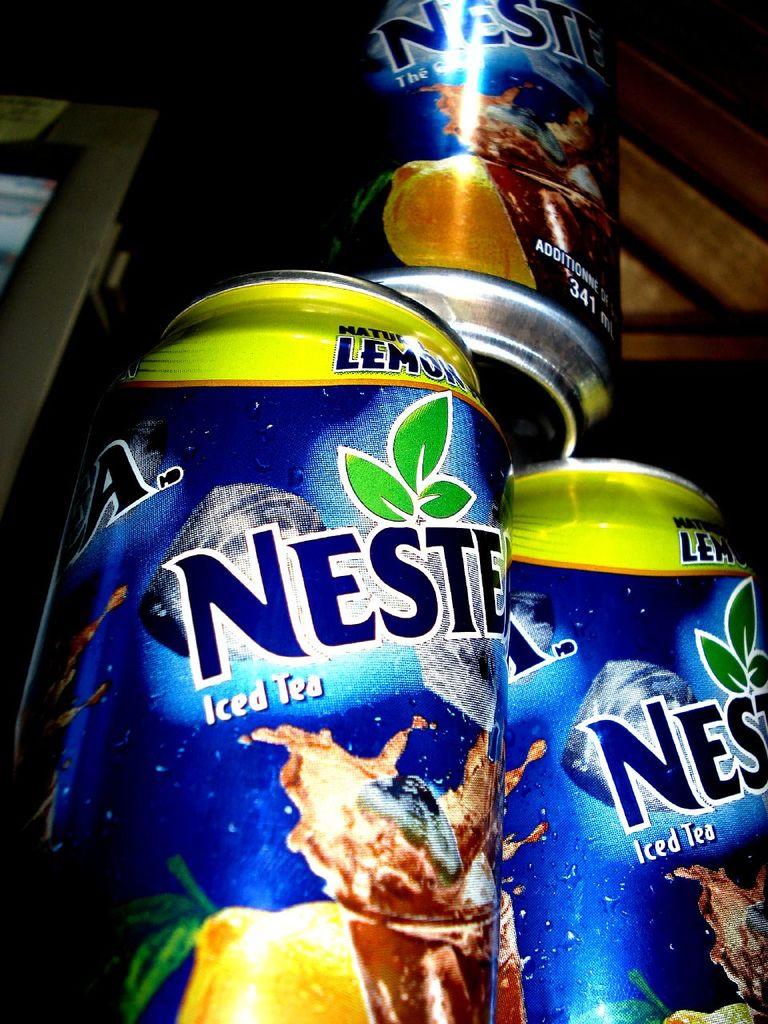What type of drink is this?
Keep it short and to the point. Iced tea. What flavor of tea is shown?
Your answer should be very brief. Lemon. 